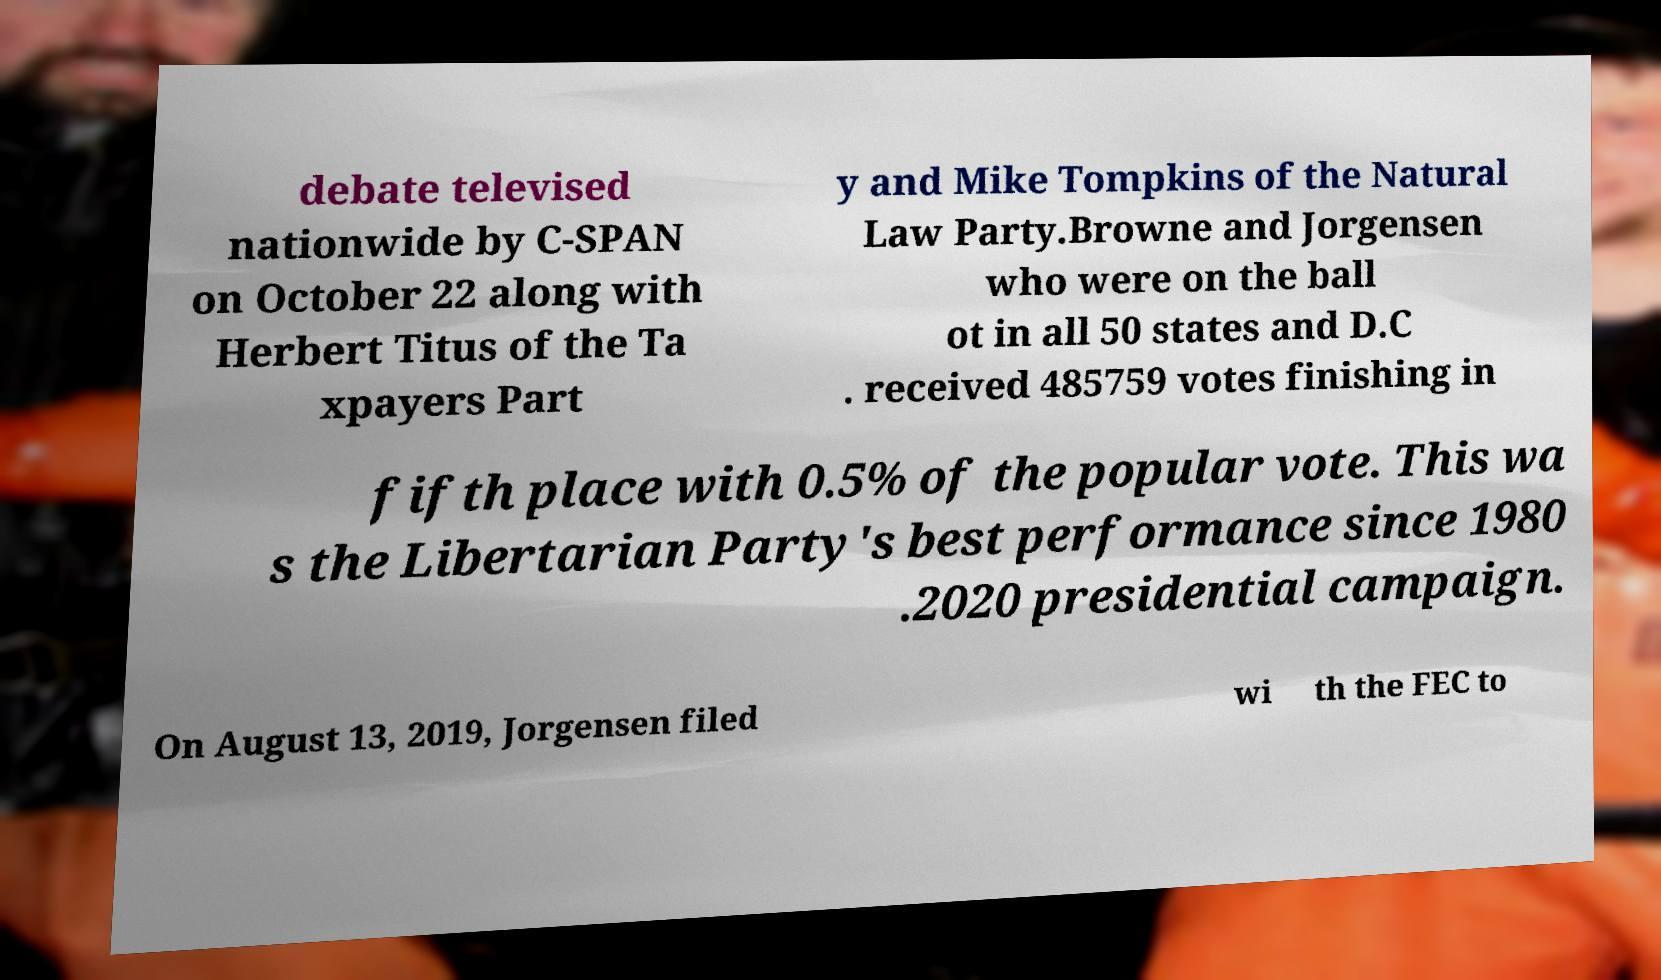Could you extract and type out the text from this image? debate televised nationwide by C-SPAN on October 22 along with Herbert Titus of the Ta xpayers Part y and Mike Tompkins of the Natural Law Party.Browne and Jorgensen who were on the ball ot in all 50 states and D.C . received 485759 votes finishing in fifth place with 0.5% of the popular vote. This wa s the Libertarian Party's best performance since 1980 .2020 presidential campaign. On August 13, 2019, Jorgensen filed wi th the FEC to 